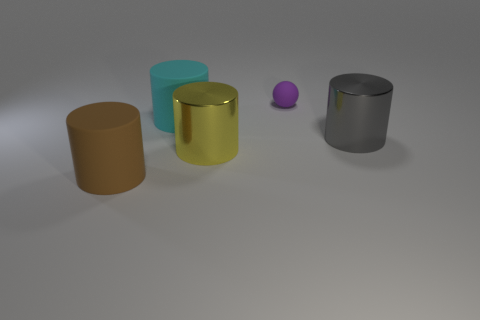Subtract 1 cylinders. How many cylinders are left? 3 Add 5 big green rubber balls. How many objects exist? 10 Subtract all spheres. How many objects are left? 4 Subtract 0 cyan balls. How many objects are left? 5 Subtract all tiny gray objects. Subtract all big brown things. How many objects are left? 4 Add 5 small rubber objects. How many small rubber objects are left? 6 Add 5 shiny things. How many shiny things exist? 7 